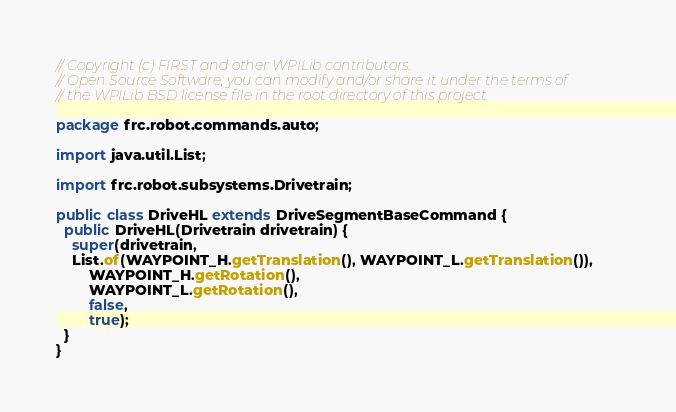<code> <loc_0><loc_0><loc_500><loc_500><_Java_>// Copyright (c) FIRST and other WPILib contributors.
// Open Source Software; you can modify and/or share it under the terms of
// the WPILib BSD license file in the root directory of this project.

package frc.robot.commands.auto;

import java.util.List;

import frc.robot.subsystems.Drivetrain;

public class DriveHL extends DriveSegmentBaseCommand {
  public DriveHL(Drivetrain drivetrain) {
    super(drivetrain, 
    List.of(WAYPOINT_H.getTranslation(), WAYPOINT_L.getTranslation()),
        WAYPOINT_H.getRotation(),
        WAYPOINT_L.getRotation(),
        false,
        true);
  }
}
</code> 